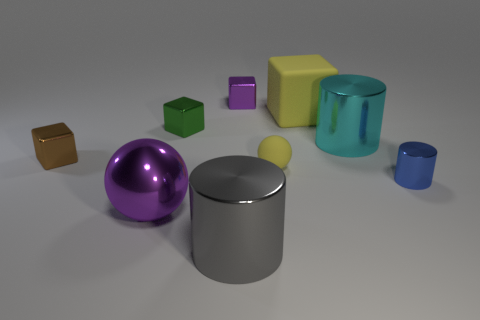The large cube has what color?
Your answer should be compact. Yellow. Are there any cyan cylinders that have the same material as the big yellow block?
Keep it short and to the point. No. There is a matte object that is in front of the big metal cylinder behind the blue cylinder; are there any metallic cylinders left of it?
Provide a short and direct response. Yes. Are there any small metal blocks to the right of the gray shiny cylinder?
Offer a very short reply. Yes. Are there any small things that have the same color as the matte cube?
Your answer should be compact. Yes. How many large objects are either gray matte objects or brown shiny objects?
Your answer should be very brief. 0. Are the yellow object that is in front of the brown object and the green cube made of the same material?
Keep it short and to the point. No. There is a rubber object in front of the cube left of the sphere in front of the tiny blue object; what shape is it?
Provide a short and direct response. Sphere. How many blue objects are either small metallic cylinders or matte blocks?
Make the answer very short. 1. Are there the same number of rubber spheres that are on the left side of the small purple cube and brown shiny things that are behind the large yellow matte object?
Your answer should be compact. Yes. 